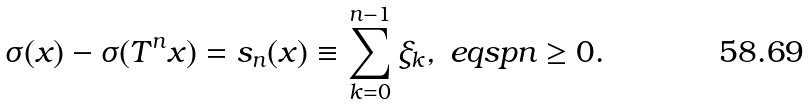<formula> <loc_0><loc_0><loc_500><loc_500>\sigma ( x ) - \sigma ( T ^ { n } x ) = s _ { n } ( x ) \equiv \sum _ { k = 0 } ^ { n - 1 } \xi _ { k } , \ e q s p n \geq 0 .</formula> 